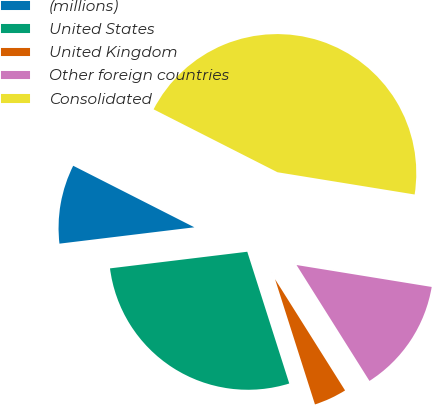<chart> <loc_0><loc_0><loc_500><loc_500><pie_chart><fcel>(millions)<fcel>United States<fcel>United Kingdom<fcel>Other foreign countries<fcel>Consolidated<nl><fcel>9.4%<fcel>27.99%<fcel>4.03%<fcel>13.5%<fcel>45.08%<nl></chart> 